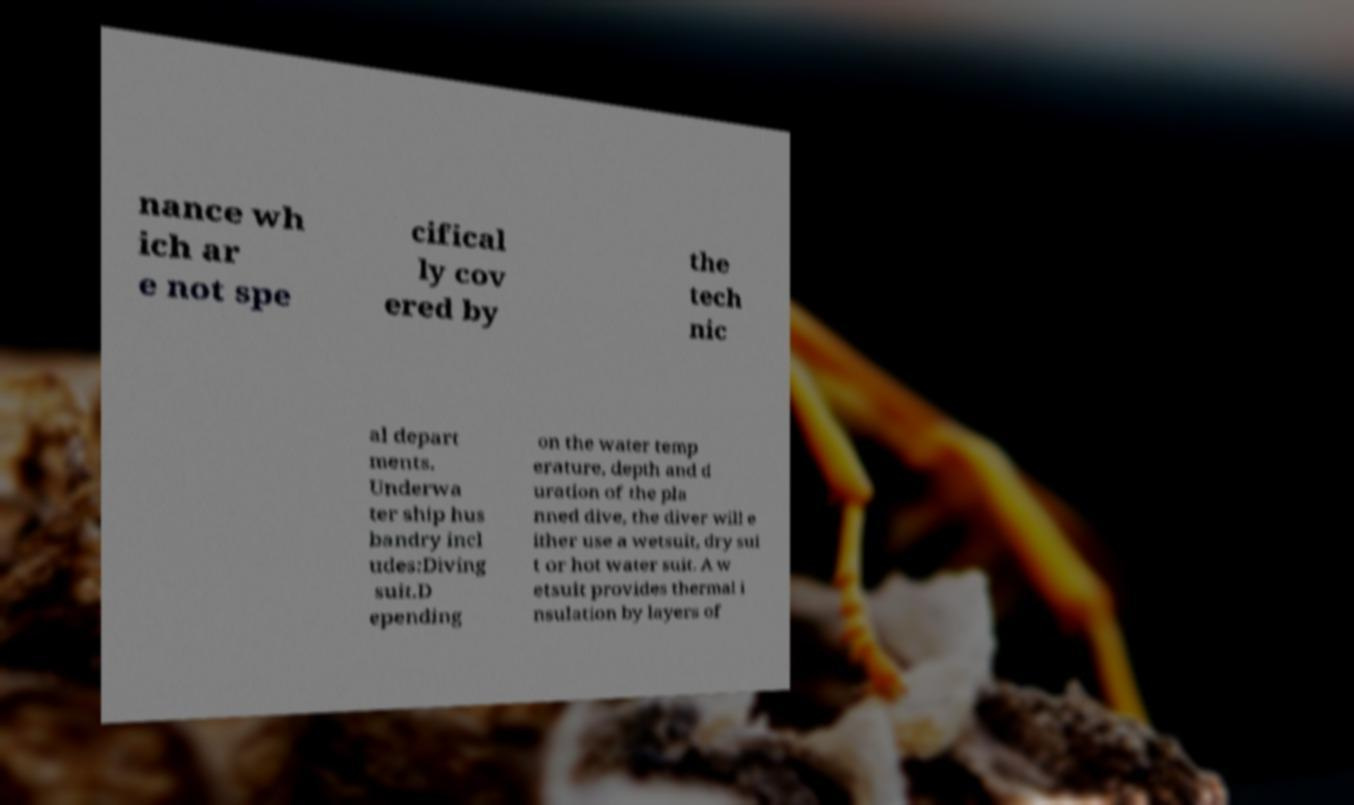Please read and relay the text visible in this image. What does it say? nance wh ich ar e not spe cifical ly cov ered by the tech nic al depart ments. Underwa ter ship hus bandry incl udes:Diving suit.D epending on the water temp erature, depth and d uration of the pla nned dive, the diver will e ither use a wetsuit, dry sui t or hot water suit. A w etsuit provides thermal i nsulation by layers of 